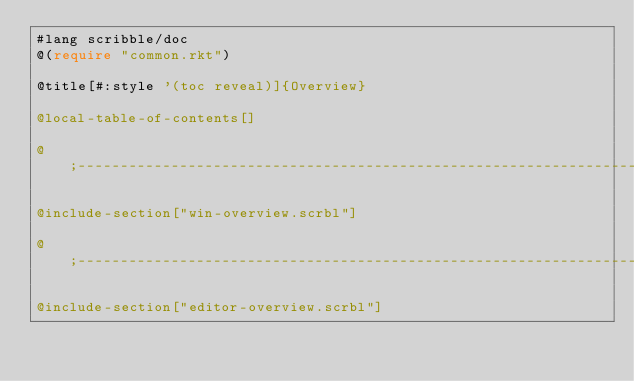<code> <loc_0><loc_0><loc_500><loc_500><_Racket_>#lang scribble/doc
@(require "common.rkt")

@title[#:style '(toc reveal)]{Overview}

@local-table-of-contents[]

@;------------------------------------------------------------------------

@include-section["win-overview.scrbl"]

@;------------------------------------------------------------------------

@include-section["editor-overview.scrbl"]
</code> 